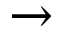Convert formula to latex. <formula><loc_0><loc_0><loc_500><loc_500>\rightarrow</formula> 